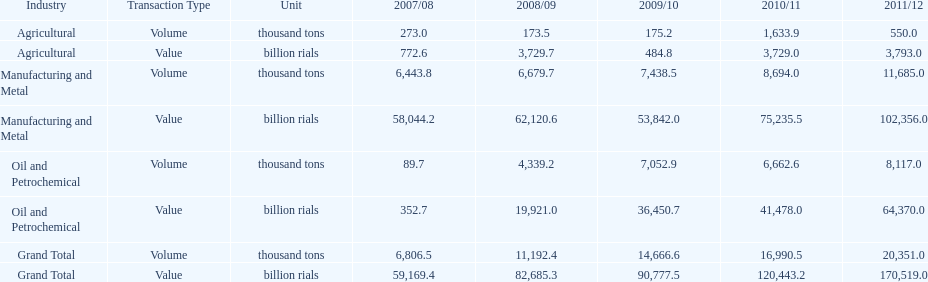What is the total agricultural value in 2008/09? 3,729.7. Parse the full table. {'header': ['Industry', 'Transaction Type', 'Unit', '2007/08', '2008/09', '2009/10', '2010/11', '2011/12'], 'rows': [['Agricultural', 'Volume', 'thousand tons', '273.0', '173.5', '175.2', '1,633.9', '550.0'], ['Agricultural', 'Value', 'billion rials', '772.6', '3,729.7', '484.8', '3,729.0', '3,793.0'], ['Manufacturing and Metal', 'Volume', 'thousand tons', '6,443.8', '6,679.7', '7,438.5', '8,694.0', '11,685.0'], ['Manufacturing and Metal', 'Value', 'billion rials', '58,044.2', '62,120.6', '53,842.0', '75,235.5', '102,356.0'], ['Oil and Petrochemical', 'Volume', 'thousand tons', '89.7', '4,339.2', '7,052.9', '6,662.6', '8,117.0'], ['Oil and Petrochemical', 'Value', 'billion rials', '352.7', '19,921.0', '36,450.7', '41,478.0', '64,370.0'], ['Grand Total', 'Volume', 'thousand tons', '6,806.5', '11,192.4', '14,666.6', '16,990.5', '20,351.0'], ['Grand Total', 'Value', 'billion rials', '59,169.4', '82,685.3', '90,777.5', '120,443.2', '170,519.0']]} 